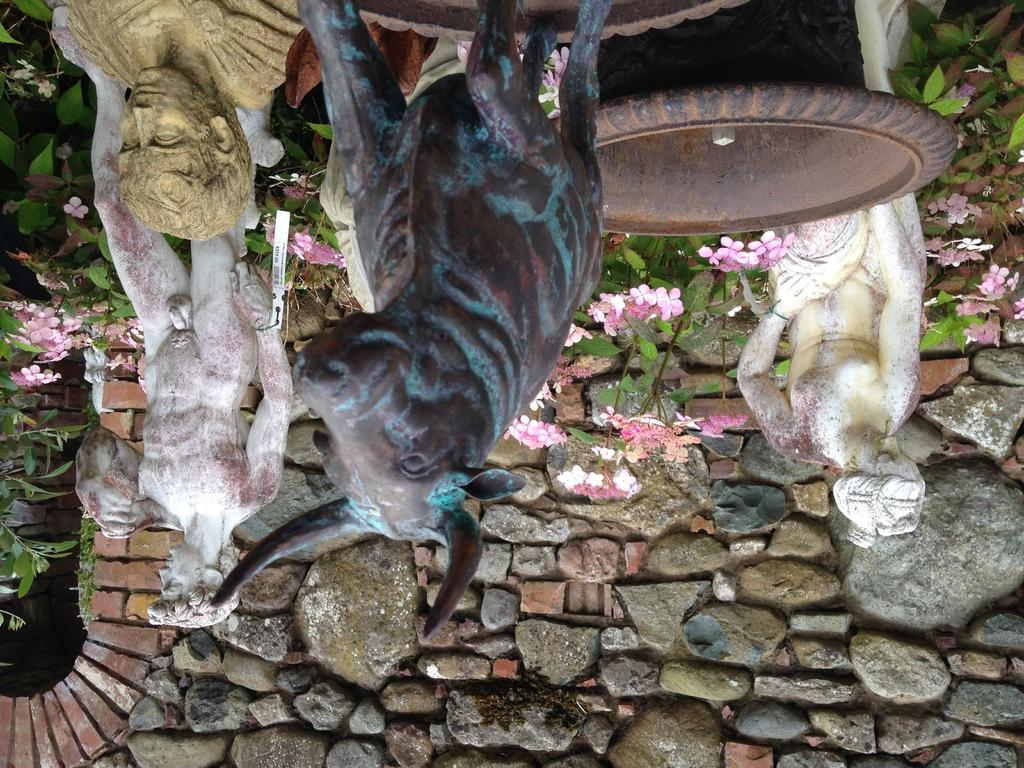What is the main subject in the middle of the picture? There is a sculpture in the middle of the picture. What can be seen in the background of the picture? There are plants and flowers in the background of the picture. What material is the wall at the bottom of the image made of? The wall at the bottom of the image is made of stone. What type of reaction can be seen from the cat in the image? There is no cat present in the image, so it is not possible to determine any reaction. 